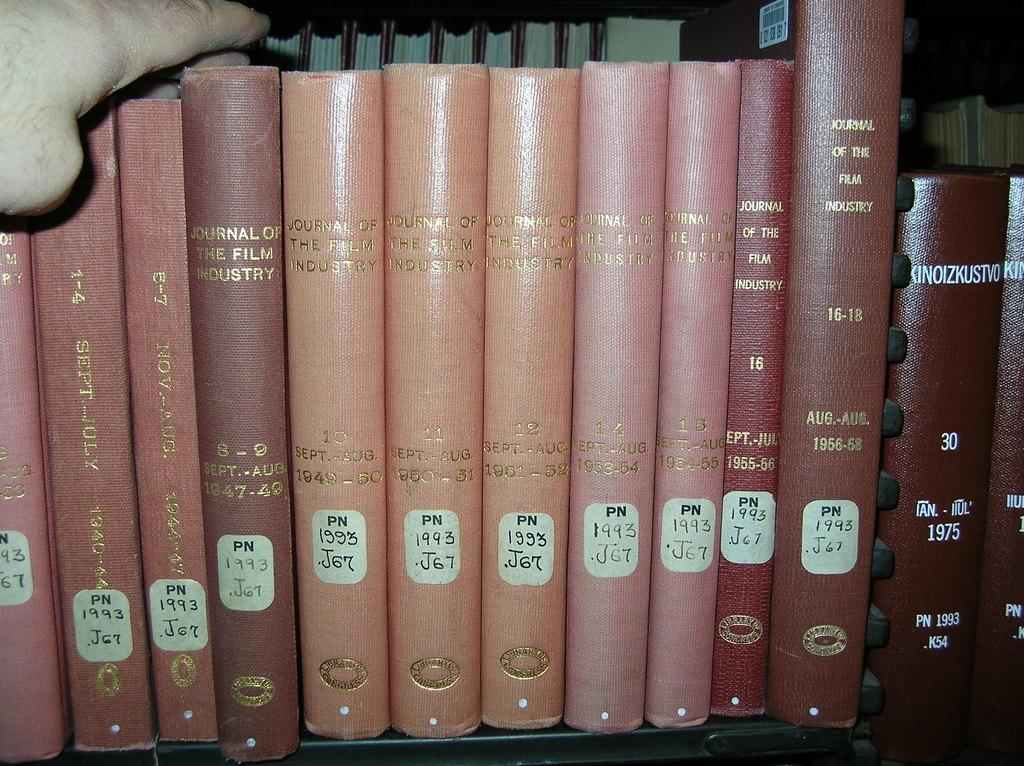<image>
Present a compact description of the photo's key features. A series of books operate as volumes of an entire set called Journal of the Film Industry. 